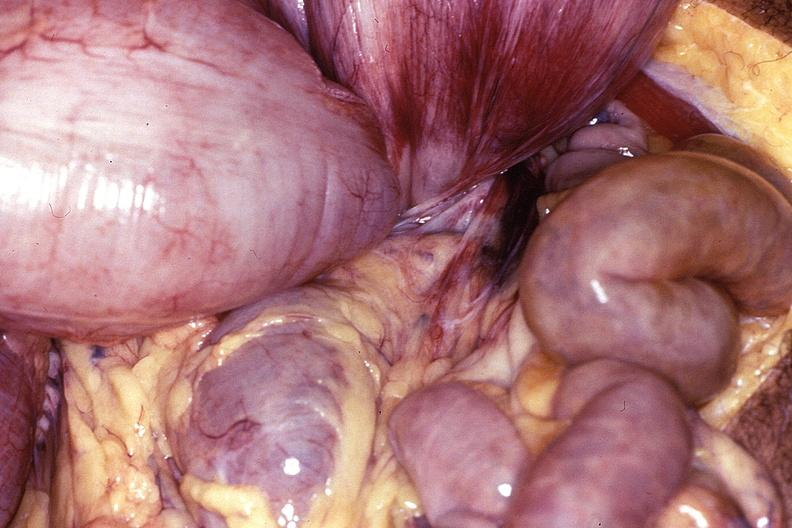what is present?
Answer the question using a single word or phrase. Gastrointestinal 